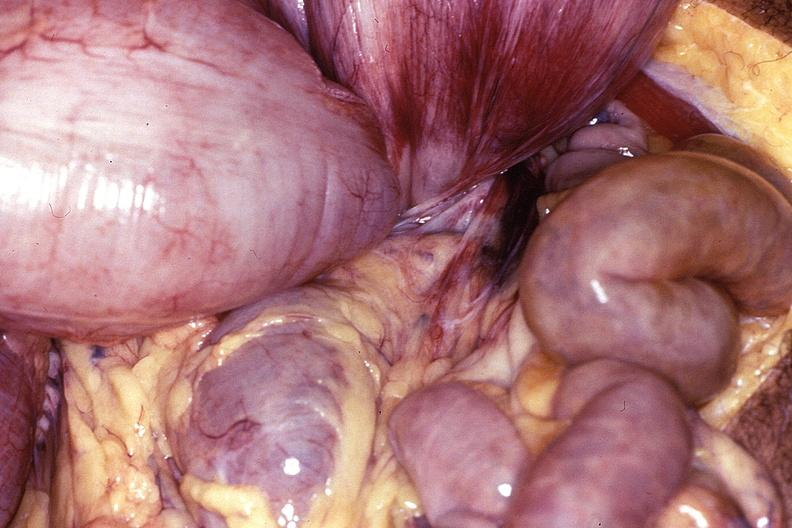what is present?
Answer the question using a single word or phrase. Gastrointestinal 